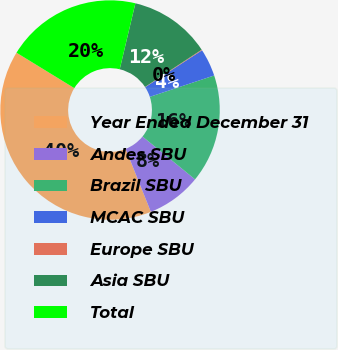Convert chart to OTSL. <chart><loc_0><loc_0><loc_500><loc_500><pie_chart><fcel>Year Ended December 31<fcel>Andes SBU<fcel>Brazil SBU<fcel>MCAC SBU<fcel>Europe SBU<fcel>Asia SBU<fcel>Total<nl><fcel>39.82%<fcel>8.04%<fcel>15.99%<fcel>4.07%<fcel>0.1%<fcel>12.02%<fcel>19.96%<nl></chart> 